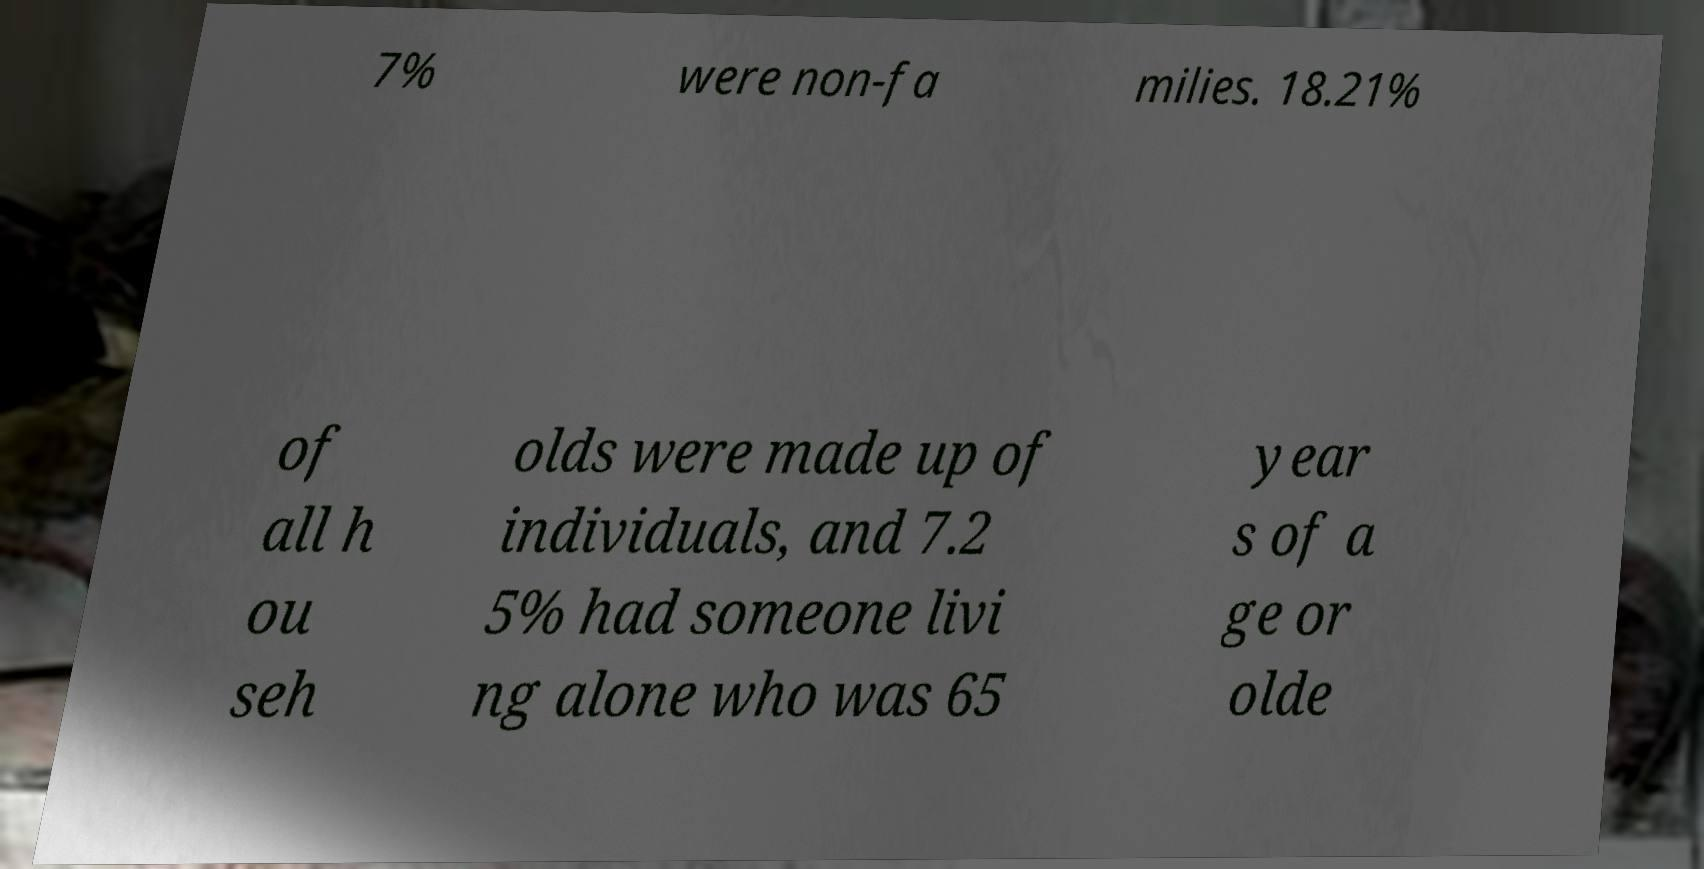Please read and relay the text visible in this image. What does it say? 7% were non-fa milies. 18.21% of all h ou seh olds were made up of individuals, and 7.2 5% had someone livi ng alone who was 65 year s of a ge or olde 